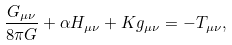<formula> <loc_0><loc_0><loc_500><loc_500>\frac { G _ { \mu \nu } } { 8 \pi G } + \alpha H _ { \mu \nu } + K g _ { \mu \nu } = - T _ { \mu \nu } ,</formula> 